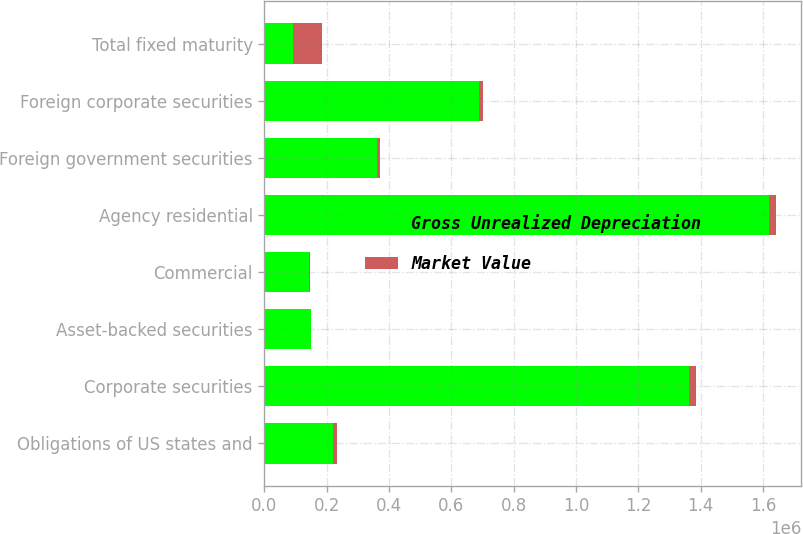<chart> <loc_0><loc_0><loc_500><loc_500><stacked_bar_chart><ecel><fcel>Obligations of US states and<fcel>Corporate securities<fcel>Asset-backed securities<fcel>Commercial<fcel>Agency residential<fcel>Foreign government securities<fcel>Foreign corporate securities<fcel>Total fixed maturity<nl><fcel>Gross Unrealized Depreciation<fcel>221088<fcel>1.36074e+06<fcel>150023<fcel>143554<fcel>1.61837e+06<fcel>360289<fcel>687599<fcel>91871<nl><fcel>Market Value<fcel>11486<fcel>24023<fcel>565<fcel>3223<fcel>22461<fcel>12041<fcel>12769<fcel>91871<nl></chart> 